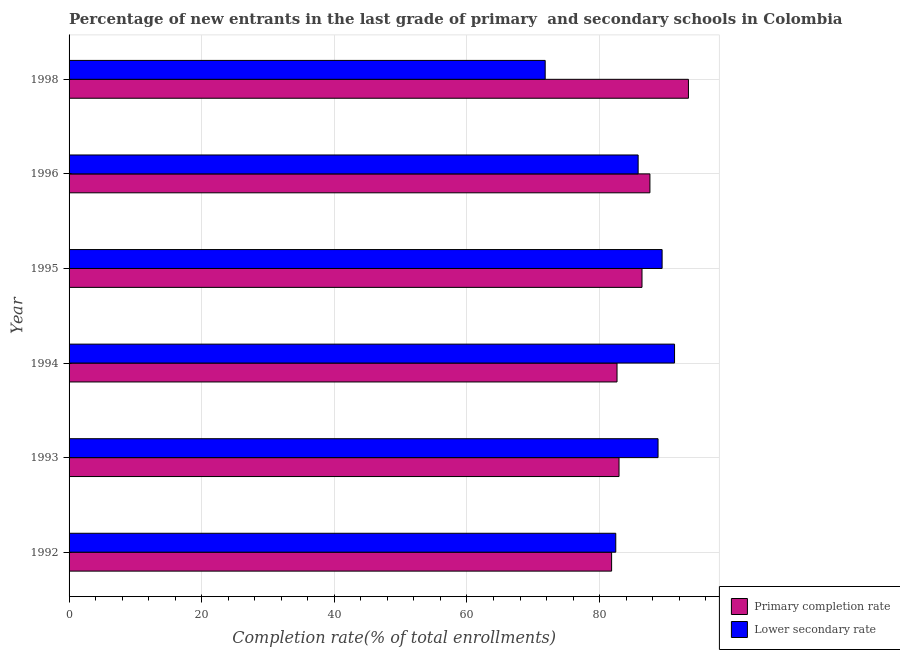How many different coloured bars are there?
Offer a terse response. 2. How many bars are there on the 4th tick from the top?
Make the answer very short. 2. How many bars are there on the 5th tick from the bottom?
Give a very brief answer. 2. In how many cases, is the number of bars for a given year not equal to the number of legend labels?
Your answer should be compact. 0. What is the completion rate in primary schools in 1995?
Provide a short and direct response. 86.39. Across all years, what is the maximum completion rate in primary schools?
Give a very brief answer. 93.4. Across all years, what is the minimum completion rate in primary schools?
Provide a short and direct response. 81.81. In which year was the completion rate in secondary schools minimum?
Your answer should be very brief. 1998. What is the total completion rate in secondary schools in the graph?
Offer a terse response. 509.59. What is the difference between the completion rate in primary schools in 1996 and that in 1998?
Provide a succinct answer. -5.81. What is the difference between the completion rate in primary schools in 1996 and the completion rate in secondary schools in 1993?
Your response must be concise. -1.22. What is the average completion rate in primary schools per year?
Provide a short and direct response. 85.79. In the year 1993, what is the difference between the completion rate in secondary schools and completion rate in primary schools?
Make the answer very short. 5.88. What is the ratio of the completion rate in secondary schools in 1993 to that in 1998?
Keep it short and to the point. 1.24. What is the difference between the highest and the second highest completion rate in primary schools?
Make the answer very short. 5.81. What is the difference between the highest and the lowest completion rate in primary schools?
Make the answer very short. 11.58. Is the sum of the completion rate in primary schools in 1994 and 1995 greater than the maximum completion rate in secondary schools across all years?
Give a very brief answer. Yes. What does the 2nd bar from the top in 1995 represents?
Your answer should be compact. Primary completion rate. What does the 2nd bar from the bottom in 1993 represents?
Keep it short and to the point. Lower secondary rate. Are all the bars in the graph horizontal?
Provide a succinct answer. Yes. Are the values on the major ticks of X-axis written in scientific E-notation?
Offer a terse response. No. Does the graph contain grids?
Keep it short and to the point. Yes. Where does the legend appear in the graph?
Give a very brief answer. Bottom right. How are the legend labels stacked?
Your answer should be compact. Vertical. What is the title of the graph?
Give a very brief answer. Percentage of new entrants in the last grade of primary  and secondary schools in Colombia. What is the label or title of the X-axis?
Your answer should be compact. Completion rate(% of total enrollments). What is the Completion rate(% of total enrollments) of Primary completion rate in 1992?
Make the answer very short. 81.81. What is the Completion rate(% of total enrollments) in Lower secondary rate in 1992?
Keep it short and to the point. 82.44. What is the Completion rate(% of total enrollments) in Primary completion rate in 1993?
Ensure brevity in your answer.  82.93. What is the Completion rate(% of total enrollments) in Lower secondary rate in 1993?
Ensure brevity in your answer.  88.81. What is the Completion rate(% of total enrollments) of Primary completion rate in 1994?
Offer a terse response. 82.63. What is the Completion rate(% of total enrollments) in Lower secondary rate in 1994?
Provide a succinct answer. 91.3. What is the Completion rate(% of total enrollments) of Primary completion rate in 1995?
Provide a succinct answer. 86.39. What is the Completion rate(% of total enrollments) of Lower secondary rate in 1995?
Ensure brevity in your answer.  89.43. What is the Completion rate(% of total enrollments) in Primary completion rate in 1996?
Provide a short and direct response. 87.59. What is the Completion rate(% of total enrollments) of Lower secondary rate in 1996?
Provide a succinct answer. 85.81. What is the Completion rate(% of total enrollments) in Primary completion rate in 1998?
Make the answer very short. 93.4. What is the Completion rate(% of total enrollments) of Lower secondary rate in 1998?
Make the answer very short. 71.8. Across all years, what is the maximum Completion rate(% of total enrollments) of Primary completion rate?
Provide a succinct answer. 93.4. Across all years, what is the maximum Completion rate(% of total enrollments) in Lower secondary rate?
Provide a short and direct response. 91.3. Across all years, what is the minimum Completion rate(% of total enrollments) of Primary completion rate?
Offer a very short reply. 81.81. Across all years, what is the minimum Completion rate(% of total enrollments) of Lower secondary rate?
Make the answer very short. 71.8. What is the total Completion rate(% of total enrollments) in Primary completion rate in the graph?
Keep it short and to the point. 514.75. What is the total Completion rate(% of total enrollments) of Lower secondary rate in the graph?
Offer a terse response. 509.59. What is the difference between the Completion rate(% of total enrollments) of Primary completion rate in 1992 and that in 1993?
Give a very brief answer. -1.12. What is the difference between the Completion rate(% of total enrollments) in Lower secondary rate in 1992 and that in 1993?
Your answer should be compact. -6.37. What is the difference between the Completion rate(% of total enrollments) of Primary completion rate in 1992 and that in 1994?
Your response must be concise. -0.82. What is the difference between the Completion rate(% of total enrollments) of Lower secondary rate in 1992 and that in 1994?
Provide a short and direct response. -8.86. What is the difference between the Completion rate(% of total enrollments) of Primary completion rate in 1992 and that in 1995?
Your answer should be very brief. -4.58. What is the difference between the Completion rate(% of total enrollments) in Lower secondary rate in 1992 and that in 1995?
Offer a very short reply. -6.99. What is the difference between the Completion rate(% of total enrollments) of Primary completion rate in 1992 and that in 1996?
Ensure brevity in your answer.  -5.78. What is the difference between the Completion rate(% of total enrollments) of Lower secondary rate in 1992 and that in 1996?
Provide a succinct answer. -3.37. What is the difference between the Completion rate(% of total enrollments) of Primary completion rate in 1992 and that in 1998?
Ensure brevity in your answer.  -11.58. What is the difference between the Completion rate(% of total enrollments) in Lower secondary rate in 1992 and that in 1998?
Give a very brief answer. 10.64. What is the difference between the Completion rate(% of total enrollments) of Primary completion rate in 1993 and that in 1994?
Provide a short and direct response. 0.3. What is the difference between the Completion rate(% of total enrollments) in Lower secondary rate in 1993 and that in 1994?
Keep it short and to the point. -2.49. What is the difference between the Completion rate(% of total enrollments) of Primary completion rate in 1993 and that in 1995?
Offer a terse response. -3.47. What is the difference between the Completion rate(% of total enrollments) in Lower secondary rate in 1993 and that in 1995?
Give a very brief answer. -0.61. What is the difference between the Completion rate(% of total enrollments) in Primary completion rate in 1993 and that in 1996?
Provide a short and direct response. -4.66. What is the difference between the Completion rate(% of total enrollments) of Lower secondary rate in 1993 and that in 1996?
Your response must be concise. 3. What is the difference between the Completion rate(% of total enrollments) in Primary completion rate in 1993 and that in 1998?
Your response must be concise. -10.47. What is the difference between the Completion rate(% of total enrollments) in Lower secondary rate in 1993 and that in 1998?
Give a very brief answer. 17.02. What is the difference between the Completion rate(% of total enrollments) of Primary completion rate in 1994 and that in 1995?
Your answer should be very brief. -3.77. What is the difference between the Completion rate(% of total enrollments) in Lower secondary rate in 1994 and that in 1995?
Give a very brief answer. 1.88. What is the difference between the Completion rate(% of total enrollments) in Primary completion rate in 1994 and that in 1996?
Your answer should be compact. -4.96. What is the difference between the Completion rate(% of total enrollments) of Lower secondary rate in 1994 and that in 1996?
Provide a short and direct response. 5.49. What is the difference between the Completion rate(% of total enrollments) in Primary completion rate in 1994 and that in 1998?
Offer a terse response. -10.77. What is the difference between the Completion rate(% of total enrollments) in Lower secondary rate in 1994 and that in 1998?
Offer a terse response. 19.51. What is the difference between the Completion rate(% of total enrollments) of Primary completion rate in 1995 and that in 1996?
Your answer should be compact. -1.19. What is the difference between the Completion rate(% of total enrollments) in Lower secondary rate in 1995 and that in 1996?
Make the answer very short. 3.61. What is the difference between the Completion rate(% of total enrollments) of Primary completion rate in 1995 and that in 1998?
Your response must be concise. -7. What is the difference between the Completion rate(% of total enrollments) of Lower secondary rate in 1995 and that in 1998?
Make the answer very short. 17.63. What is the difference between the Completion rate(% of total enrollments) in Primary completion rate in 1996 and that in 1998?
Offer a terse response. -5.81. What is the difference between the Completion rate(% of total enrollments) in Lower secondary rate in 1996 and that in 1998?
Keep it short and to the point. 14.02. What is the difference between the Completion rate(% of total enrollments) in Primary completion rate in 1992 and the Completion rate(% of total enrollments) in Lower secondary rate in 1993?
Offer a very short reply. -7. What is the difference between the Completion rate(% of total enrollments) in Primary completion rate in 1992 and the Completion rate(% of total enrollments) in Lower secondary rate in 1994?
Offer a terse response. -9.49. What is the difference between the Completion rate(% of total enrollments) in Primary completion rate in 1992 and the Completion rate(% of total enrollments) in Lower secondary rate in 1995?
Offer a terse response. -7.61. What is the difference between the Completion rate(% of total enrollments) of Primary completion rate in 1992 and the Completion rate(% of total enrollments) of Lower secondary rate in 1996?
Give a very brief answer. -4. What is the difference between the Completion rate(% of total enrollments) in Primary completion rate in 1992 and the Completion rate(% of total enrollments) in Lower secondary rate in 1998?
Your answer should be very brief. 10.02. What is the difference between the Completion rate(% of total enrollments) of Primary completion rate in 1993 and the Completion rate(% of total enrollments) of Lower secondary rate in 1994?
Give a very brief answer. -8.37. What is the difference between the Completion rate(% of total enrollments) of Primary completion rate in 1993 and the Completion rate(% of total enrollments) of Lower secondary rate in 1995?
Offer a terse response. -6.5. What is the difference between the Completion rate(% of total enrollments) in Primary completion rate in 1993 and the Completion rate(% of total enrollments) in Lower secondary rate in 1996?
Offer a terse response. -2.88. What is the difference between the Completion rate(% of total enrollments) in Primary completion rate in 1993 and the Completion rate(% of total enrollments) in Lower secondary rate in 1998?
Provide a succinct answer. 11.13. What is the difference between the Completion rate(% of total enrollments) in Primary completion rate in 1994 and the Completion rate(% of total enrollments) in Lower secondary rate in 1995?
Offer a terse response. -6.8. What is the difference between the Completion rate(% of total enrollments) of Primary completion rate in 1994 and the Completion rate(% of total enrollments) of Lower secondary rate in 1996?
Make the answer very short. -3.18. What is the difference between the Completion rate(% of total enrollments) of Primary completion rate in 1994 and the Completion rate(% of total enrollments) of Lower secondary rate in 1998?
Make the answer very short. 10.83. What is the difference between the Completion rate(% of total enrollments) of Primary completion rate in 1995 and the Completion rate(% of total enrollments) of Lower secondary rate in 1996?
Provide a short and direct response. 0.58. What is the difference between the Completion rate(% of total enrollments) in Primary completion rate in 1995 and the Completion rate(% of total enrollments) in Lower secondary rate in 1998?
Provide a succinct answer. 14.6. What is the difference between the Completion rate(% of total enrollments) of Primary completion rate in 1996 and the Completion rate(% of total enrollments) of Lower secondary rate in 1998?
Your response must be concise. 15.79. What is the average Completion rate(% of total enrollments) in Primary completion rate per year?
Ensure brevity in your answer.  85.79. What is the average Completion rate(% of total enrollments) of Lower secondary rate per year?
Offer a very short reply. 84.93. In the year 1992, what is the difference between the Completion rate(% of total enrollments) of Primary completion rate and Completion rate(% of total enrollments) of Lower secondary rate?
Give a very brief answer. -0.63. In the year 1993, what is the difference between the Completion rate(% of total enrollments) of Primary completion rate and Completion rate(% of total enrollments) of Lower secondary rate?
Give a very brief answer. -5.88. In the year 1994, what is the difference between the Completion rate(% of total enrollments) of Primary completion rate and Completion rate(% of total enrollments) of Lower secondary rate?
Make the answer very short. -8.67. In the year 1995, what is the difference between the Completion rate(% of total enrollments) of Primary completion rate and Completion rate(% of total enrollments) of Lower secondary rate?
Offer a very short reply. -3.03. In the year 1996, what is the difference between the Completion rate(% of total enrollments) of Primary completion rate and Completion rate(% of total enrollments) of Lower secondary rate?
Your answer should be very brief. 1.78. In the year 1998, what is the difference between the Completion rate(% of total enrollments) in Primary completion rate and Completion rate(% of total enrollments) in Lower secondary rate?
Your answer should be very brief. 21.6. What is the ratio of the Completion rate(% of total enrollments) of Primary completion rate in 1992 to that in 1993?
Your response must be concise. 0.99. What is the ratio of the Completion rate(% of total enrollments) in Lower secondary rate in 1992 to that in 1993?
Keep it short and to the point. 0.93. What is the ratio of the Completion rate(% of total enrollments) of Primary completion rate in 1992 to that in 1994?
Your answer should be compact. 0.99. What is the ratio of the Completion rate(% of total enrollments) in Lower secondary rate in 1992 to that in 1994?
Keep it short and to the point. 0.9. What is the ratio of the Completion rate(% of total enrollments) in Primary completion rate in 1992 to that in 1995?
Your answer should be very brief. 0.95. What is the ratio of the Completion rate(% of total enrollments) of Lower secondary rate in 1992 to that in 1995?
Provide a short and direct response. 0.92. What is the ratio of the Completion rate(% of total enrollments) in Primary completion rate in 1992 to that in 1996?
Your response must be concise. 0.93. What is the ratio of the Completion rate(% of total enrollments) in Lower secondary rate in 1992 to that in 1996?
Offer a terse response. 0.96. What is the ratio of the Completion rate(% of total enrollments) in Primary completion rate in 1992 to that in 1998?
Offer a very short reply. 0.88. What is the ratio of the Completion rate(% of total enrollments) of Lower secondary rate in 1992 to that in 1998?
Your answer should be very brief. 1.15. What is the ratio of the Completion rate(% of total enrollments) of Lower secondary rate in 1993 to that in 1994?
Keep it short and to the point. 0.97. What is the ratio of the Completion rate(% of total enrollments) of Primary completion rate in 1993 to that in 1995?
Keep it short and to the point. 0.96. What is the ratio of the Completion rate(% of total enrollments) of Lower secondary rate in 1993 to that in 1995?
Make the answer very short. 0.99. What is the ratio of the Completion rate(% of total enrollments) in Primary completion rate in 1993 to that in 1996?
Offer a terse response. 0.95. What is the ratio of the Completion rate(% of total enrollments) of Lower secondary rate in 1993 to that in 1996?
Keep it short and to the point. 1.03. What is the ratio of the Completion rate(% of total enrollments) of Primary completion rate in 1993 to that in 1998?
Keep it short and to the point. 0.89. What is the ratio of the Completion rate(% of total enrollments) in Lower secondary rate in 1993 to that in 1998?
Provide a succinct answer. 1.24. What is the ratio of the Completion rate(% of total enrollments) in Primary completion rate in 1994 to that in 1995?
Ensure brevity in your answer.  0.96. What is the ratio of the Completion rate(% of total enrollments) of Lower secondary rate in 1994 to that in 1995?
Offer a very short reply. 1.02. What is the ratio of the Completion rate(% of total enrollments) in Primary completion rate in 1994 to that in 1996?
Offer a terse response. 0.94. What is the ratio of the Completion rate(% of total enrollments) of Lower secondary rate in 1994 to that in 1996?
Your answer should be very brief. 1.06. What is the ratio of the Completion rate(% of total enrollments) of Primary completion rate in 1994 to that in 1998?
Keep it short and to the point. 0.88. What is the ratio of the Completion rate(% of total enrollments) of Lower secondary rate in 1994 to that in 1998?
Keep it short and to the point. 1.27. What is the ratio of the Completion rate(% of total enrollments) in Primary completion rate in 1995 to that in 1996?
Provide a succinct answer. 0.99. What is the ratio of the Completion rate(% of total enrollments) in Lower secondary rate in 1995 to that in 1996?
Give a very brief answer. 1.04. What is the ratio of the Completion rate(% of total enrollments) of Primary completion rate in 1995 to that in 1998?
Keep it short and to the point. 0.93. What is the ratio of the Completion rate(% of total enrollments) in Lower secondary rate in 1995 to that in 1998?
Offer a terse response. 1.25. What is the ratio of the Completion rate(% of total enrollments) of Primary completion rate in 1996 to that in 1998?
Give a very brief answer. 0.94. What is the ratio of the Completion rate(% of total enrollments) in Lower secondary rate in 1996 to that in 1998?
Make the answer very short. 1.2. What is the difference between the highest and the second highest Completion rate(% of total enrollments) in Primary completion rate?
Ensure brevity in your answer.  5.81. What is the difference between the highest and the second highest Completion rate(% of total enrollments) of Lower secondary rate?
Your answer should be compact. 1.88. What is the difference between the highest and the lowest Completion rate(% of total enrollments) in Primary completion rate?
Your answer should be very brief. 11.58. What is the difference between the highest and the lowest Completion rate(% of total enrollments) in Lower secondary rate?
Ensure brevity in your answer.  19.51. 